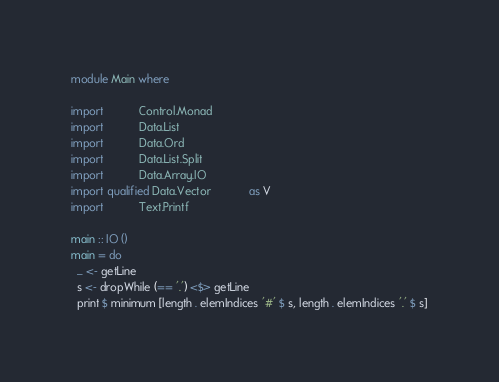Convert code to text. <code><loc_0><loc_0><loc_500><loc_500><_Haskell_>module Main where

import           Control.Monad
import           Data.List
import           Data.Ord
import           Data.List.Split
import           Data.Array.IO
import qualified Data.Vector            as V
import           Text.Printf

main :: IO ()
main = do
  _ <- getLine
  s <- dropWhile (== '.') <$> getLine
  print $ minimum [length . elemIndices '#' $ s, length . elemIndices '.' $ s]
</code> 